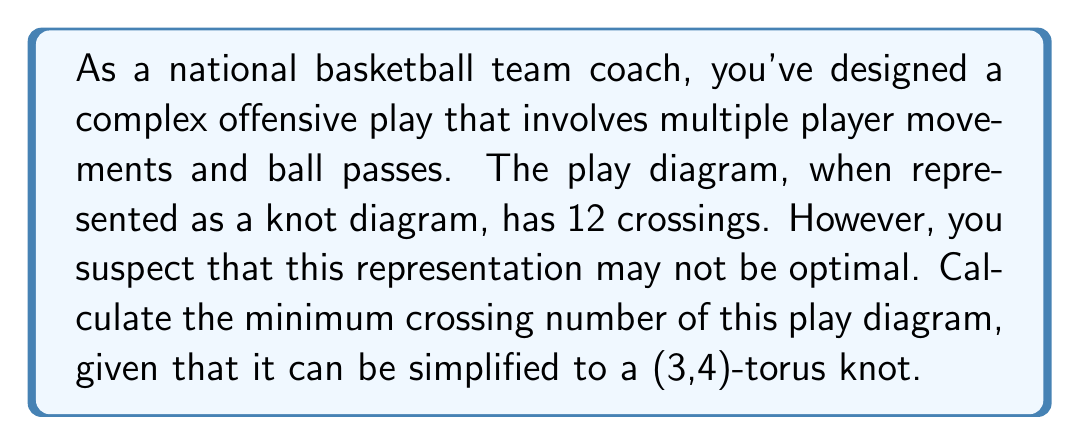Help me with this question. To solve this problem, we need to follow these steps:

1) First, recall that the play diagram can be simplified to a (3,4)-torus knot. This is crucial information for determining the minimum crossing number.

2) The crossing number of a (p,q)-torus knot, where p < q, is given by the formula:

   $$c(T_{p,q}) = (p-1)(q-1)$$

3) In this case, we have a (3,4)-torus knot, so p = 3 and q = 4.

4) Let's substitute these values into the formula:

   $$c(T_{3,4}) = (3-1)(4-1) = 2 * 3 = 6$$

5) Therefore, the minimum crossing number for this play diagram is 6.

6) Note that this is less than the original 12 crossings in the initial representation, confirming that the original diagram was indeed not optimal.

This result means that, in theory, you could simplify your play diagram to have only 6 crossings while still maintaining the same fundamental structure. This could potentially make the play easier for your players to visualize and execute.
Answer: 6 